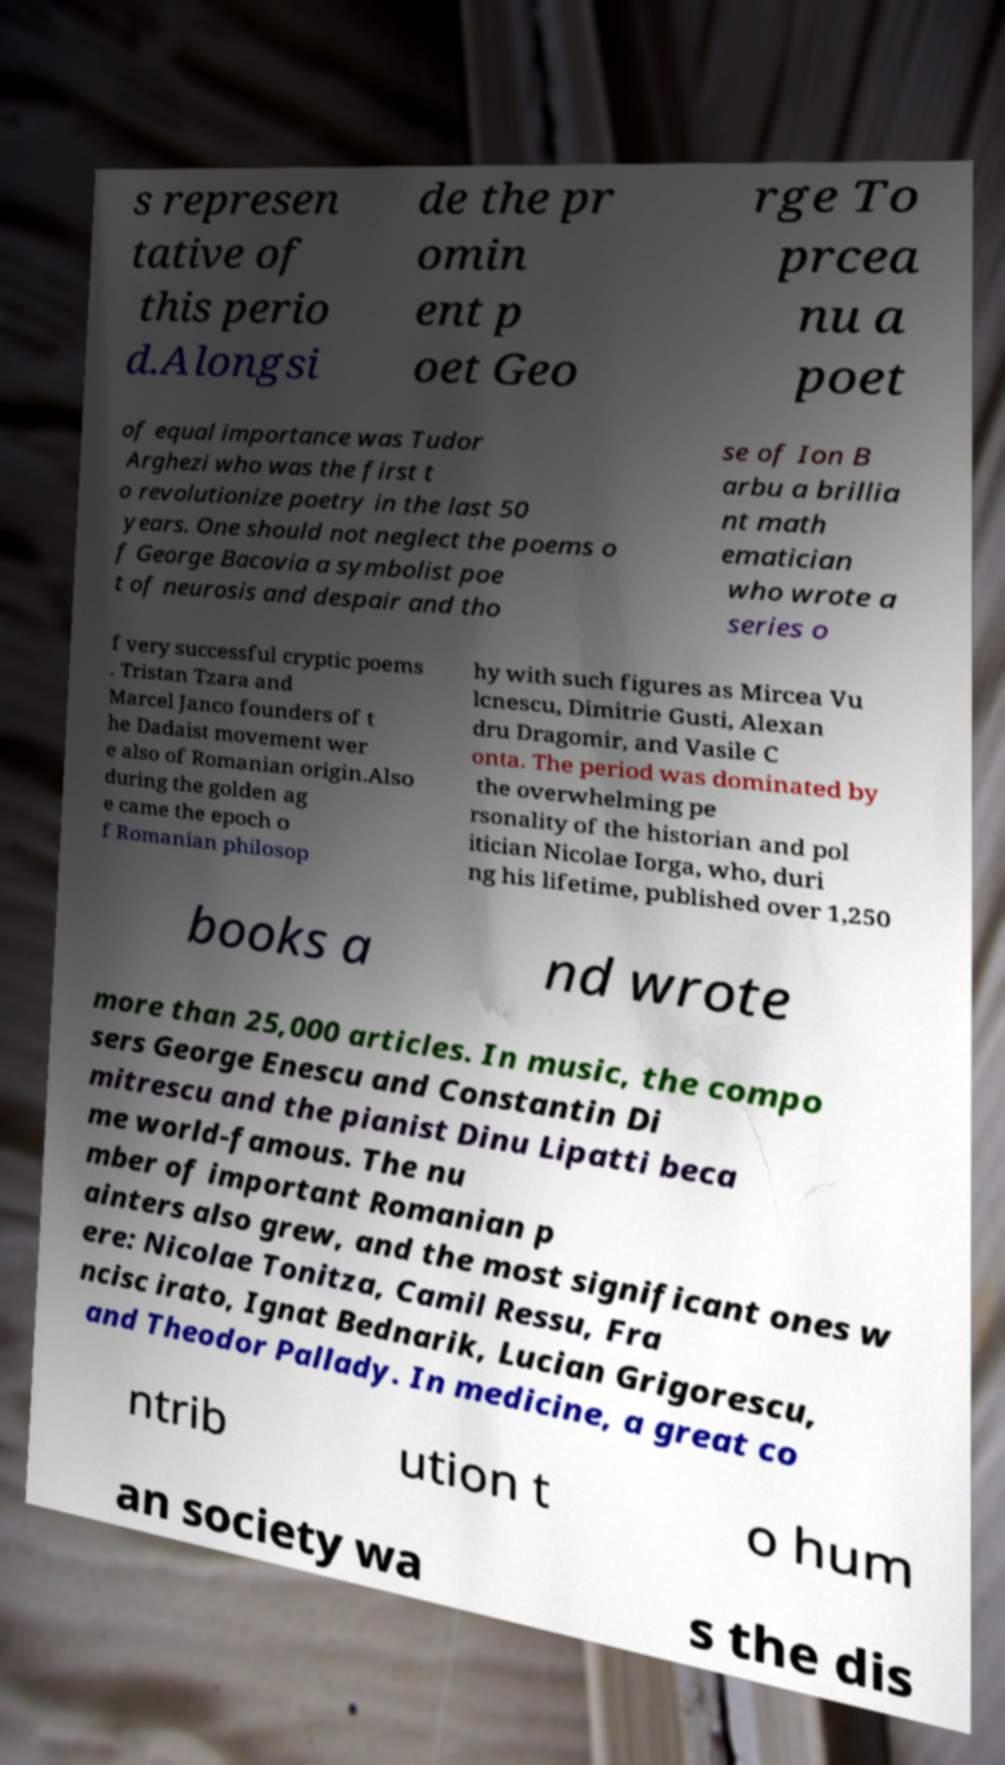Could you extract and type out the text from this image? s represen tative of this perio d.Alongsi de the pr omin ent p oet Geo rge To prcea nu a poet of equal importance was Tudor Arghezi who was the first t o revolutionize poetry in the last 50 years. One should not neglect the poems o f George Bacovia a symbolist poe t of neurosis and despair and tho se of Ion B arbu a brillia nt math ematician who wrote a series o f very successful cryptic poems . Tristan Tzara and Marcel Janco founders of t he Dadaist movement wer e also of Romanian origin.Also during the golden ag e came the epoch o f Romanian philosop hy with such figures as Mircea Vu lcnescu, Dimitrie Gusti, Alexan dru Dragomir, and Vasile C onta. The period was dominated by the overwhelming pe rsonality of the historian and pol itician Nicolae Iorga, who, duri ng his lifetime, published over 1,250 books a nd wrote more than 25,000 articles. In music, the compo sers George Enescu and Constantin Di mitrescu and the pianist Dinu Lipatti beca me world-famous. The nu mber of important Romanian p ainters also grew, and the most significant ones w ere: Nicolae Tonitza, Camil Ressu, Fra ncisc irato, Ignat Bednarik, Lucian Grigorescu, and Theodor Pallady. In medicine, a great co ntrib ution t o hum an society wa s the dis 